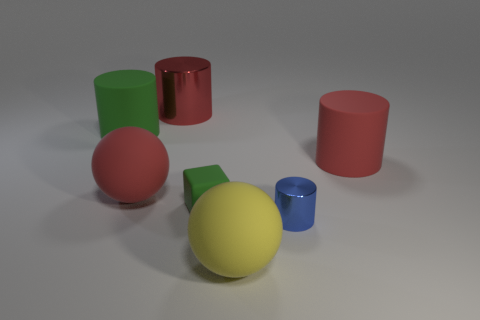Subtract all yellow balls. Subtract all purple cylinders. How many balls are left? 1 Add 1 big red cylinders. How many objects exist? 8 Subtract all cylinders. How many objects are left? 3 Subtract 0 gray cubes. How many objects are left? 7 Subtract all rubber cubes. Subtract all green cylinders. How many objects are left? 5 Add 4 big yellow things. How many big yellow things are left? 5 Add 3 rubber objects. How many rubber objects exist? 8 